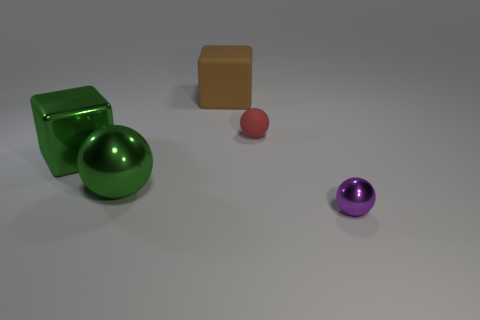There is a brown cube that is the same material as the small red sphere; what is its size?
Ensure brevity in your answer.  Large. What shape is the tiny thing on the left side of the tiny purple thing?
Offer a very short reply. Sphere. What is the size of the green shiny thing that is the same shape as the small purple thing?
Your response must be concise. Large. There is a large metallic object that is on the left side of the shiny sphere behind the purple metallic ball; what number of small red rubber spheres are behind it?
Your response must be concise. 1. Is the number of large brown cubes that are to the right of the purple object the same as the number of tiny yellow rubber objects?
Give a very brief answer. Yes. How many cylinders are big brown rubber things or small shiny objects?
Offer a terse response. 0. Is the color of the rubber block the same as the big shiny block?
Provide a succinct answer. No. Is the number of large green objects that are behind the green shiny cube the same as the number of metallic things that are to the right of the tiny red matte thing?
Your answer should be compact. No. The small matte thing is what color?
Your response must be concise. Red. How many things are either spheres to the left of the red object or brown things?
Offer a very short reply. 2. 